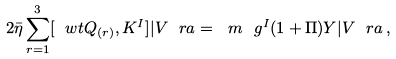<formula> <loc_0><loc_0><loc_500><loc_500>2 \bar { \eta } \sum _ { r = 1 } ^ { 3 } [ \ w t { Q } _ { ( r ) } , K ^ { I } ] | V \ r a = \ m \ g ^ { I } ( 1 + \Pi ) Y | V \ r a \, ,</formula> 